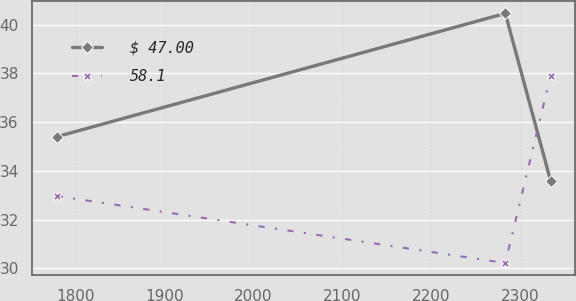<chart> <loc_0><loc_0><loc_500><loc_500><line_chart><ecel><fcel>$ 47.00<fcel>58.1<nl><fcel>1778.26<fcel>35.4<fcel>32.97<nl><fcel>2283.74<fcel>40.46<fcel>30.22<nl><fcel>2334.8<fcel>33.59<fcel>37.91<nl></chart> 